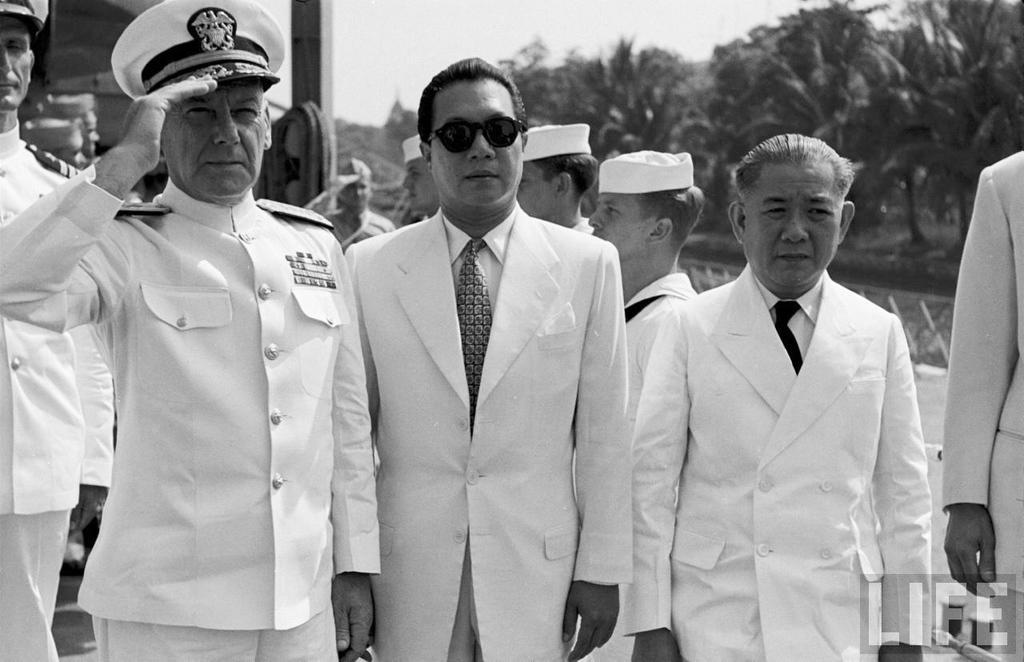How would you summarize this image in a sentence or two? In this image we can see this person wearing uniform and hat is saluting. Here we can see these people wearing blazers and ties are standing. In the background, we can see a few more people standing trees and the sky. 